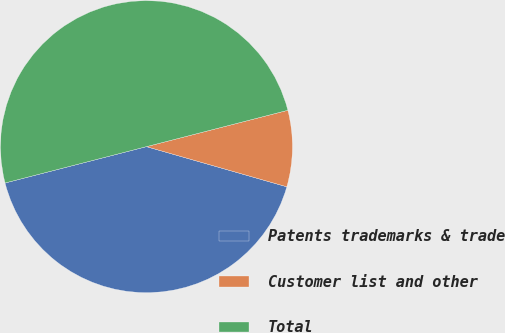Convert chart to OTSL. <chart><loc_0><loc_0><loc_500><loc_500><pie_chart><fcel>Patents trademarks & trade<fcel>Customer list and other<fcel>Total<nl><fcel>41.56%<fcel>8.44%<fcel>50.0%<nl></chart> 